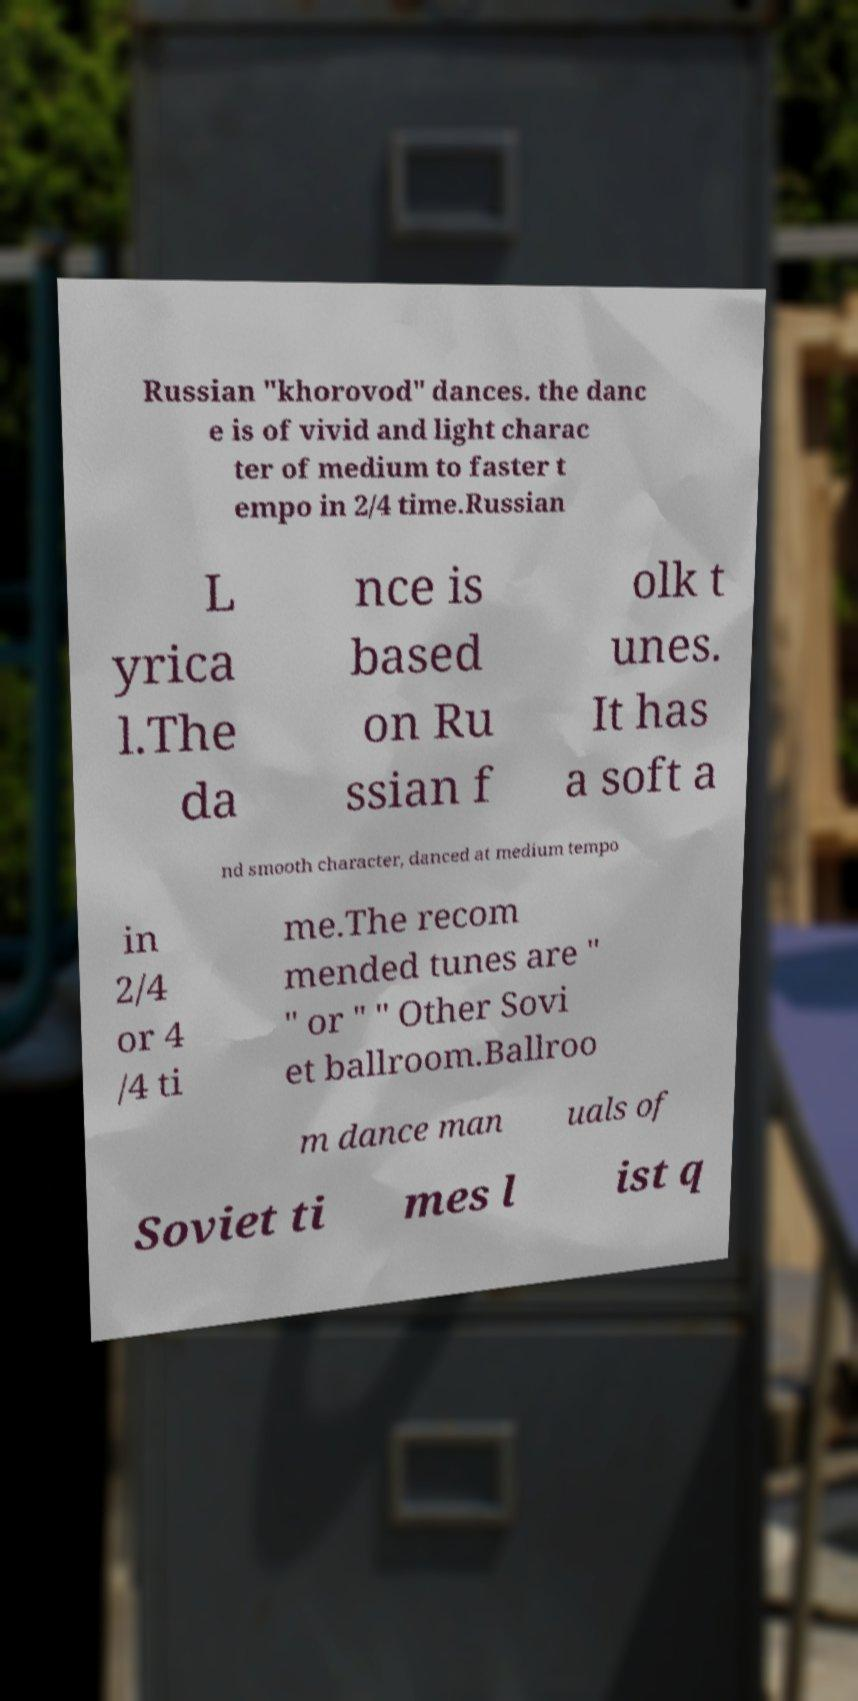For documentation purposes, I need the text within this image transcribed. Could you provide that? Russian "khorovod" dances. the danc e is of vivid and light charac ter of medium to faster t empo in 2/4 time.Russian L yrica l.The da nce is based on Ru ssian f olk t unes. It has a soft a nd smooth character, danced at medium tempo in 2/4 or 4 /4 ti me.The recom mended tunes are " " or " " Other Sovi et ballroom.Ballroo m dance man uals of Soviet ti mes l ist q 